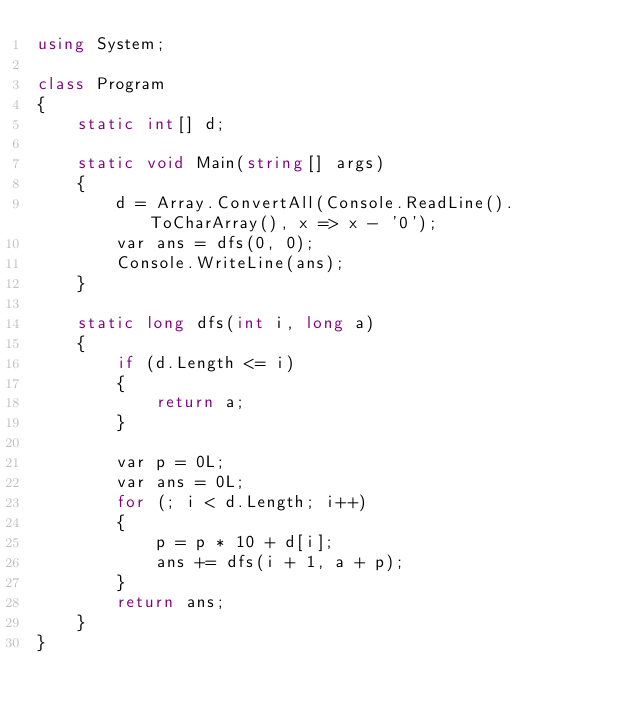<code> <loc_0><loc_0><loc_500><loc_500><_C#_>using System;

class Program
{
    static int[] d;

    static void Main(string[] args)
    {
        d = Array.ConvertAll(Console.ReadLine().ToCharArray(), x => x - '0');
        var ans = dfs(0, 0);
        Console.WriteLine(ans);
    }

    static long dfs(int i, long a)
    {
        if (d.Length <= i)
        {
            return a;
        }

        var p = 0L;
        var ans = 0L;
        for (; i < d.Length; i++)
        {
            p = p * 10 + d[i];
            ans += dfs(i + 1, a + p);
        }
        return ans;
    }
}
</code> 